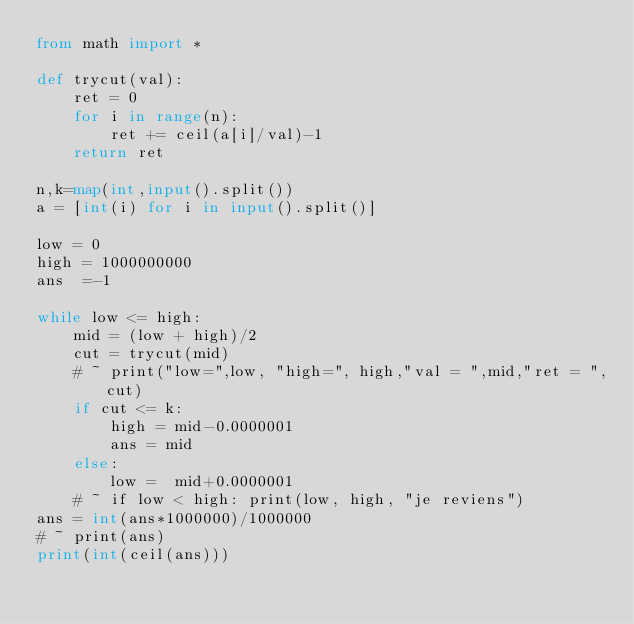Convert code to text. <code><loc_0><loc_0><loc_500><loc_500><_Python_>from math import *

def trycut(val):
	ret = 0
	for i in range(n):
		ret += ceil(a[i]/val)-1
	return ret 

n,k=map(int,input().split())
a = [int(i) for i in input().split()]

low = 0
high = 1000000000
ans  =-1

while low <= high:
	mid = (low + high)/2
	cut = trycut(mid)
	# ~ print("low=",low, "high=", high,"val = ",mid,"ret = ",cut)
	if cut <= k:
		high = mid-0.0000001
		ans = mid
	else:
		low =  mid+0.0000001
	# ~ if low < high: print(low, high, "je reviens")
ans = int(ans*1000000)/1000000
# ~ print(ans)
print(int(ceil(ans)))


</code> 